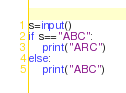Convert code to text. <code><loc_0><loc_0><loc_500><loc_500><_Python_>s=input()
if s=="ABC":
    print("ARC")
else:
    print("ABC")</code> 